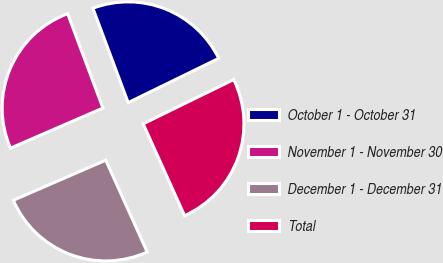Convert chart to OTSL. <chart><loc_0><loc_0><loc_500><loc_500><pie_chart><fcel>October 1 - October 31<fcel>November 1 - November 30<fcel>December 1 - December 31<fcel>Total<nl><fcel>23.46%<fcel>25.82%<fcel>25.23%<fcel>25.49%<nl></chart> 